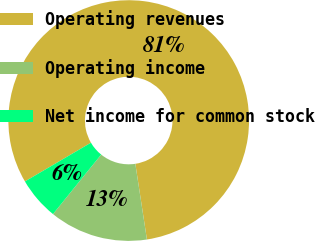Convert chart. <chart><loc_0><loc_0><loc_500><loc_500><pie_chart><fcel>Operating revenues<fcel>Operating income<fcel>Net income for common stock<nl><fcel>81.03%<fcel>13.25%<fcel>5.72%<nl></chart> 